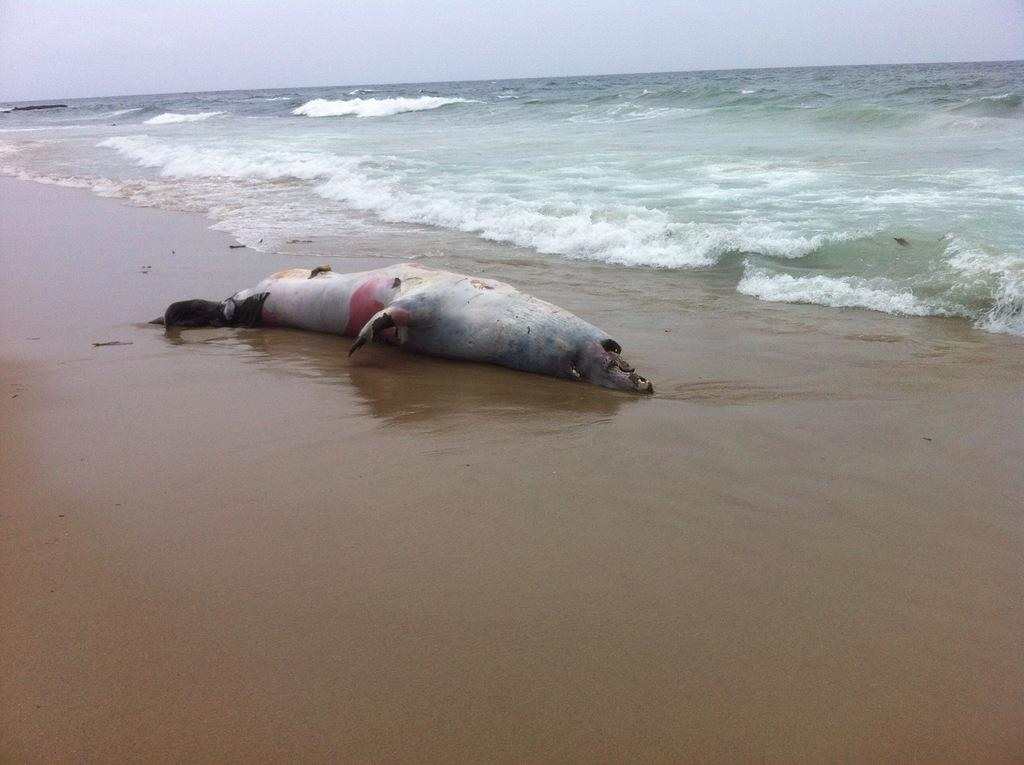What type of animal is in the image? There is a seal in the image. Where is the seal located? The seal is on the shore. What natural element is visible in the image? There is water visible in the image. What is the condition of the sky in the image? The sky appears to be cloudy in the image. What type of cable can be seen tangled up with the seal in the image? There is no cable present in the image; it features a seal on the shore. What type of stocking is the seal wearing on its front flipper in the image? There is no stocking present on the seal in the image. 